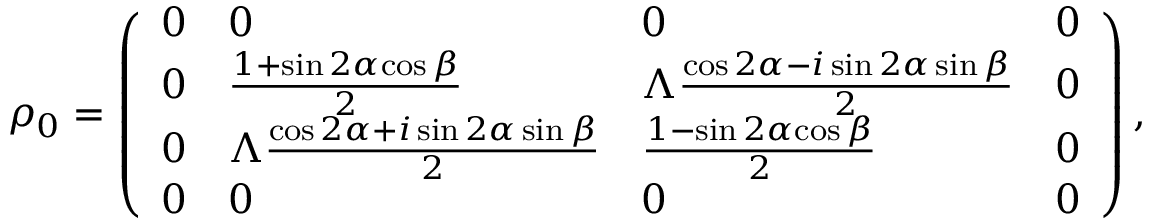<formula> <loc_0><loc_0><loc_500><loc_500>\rho _ { 0 } = \left ( \begin{array} { l l l l } { 0 } & { 0 } & { 0 } & { 0 } \\ { 0 } & { \frac { 1 + \sin { 2 \alpha } { \cos { \beta } } } { 2 } } & { \Lambda \frac { \cos { 2 \alpha } - i \sin { 2 \alpha } \sin { \beta } } { 2 } } & { 0 } \\ { 0 } & { \Lambda \frac { \cos { 2 \alpha } + i \sin { 2 \alpha } \sin { \beta } } { 2 } } & { \frac { 1 - \sin { 2 \alpha } { \cos { \beta } } } { 2 } } & { 0 } \\ { 0 } & { 0 } & { 0 } & { 0 } \end{array} \right ) ,</formula> 